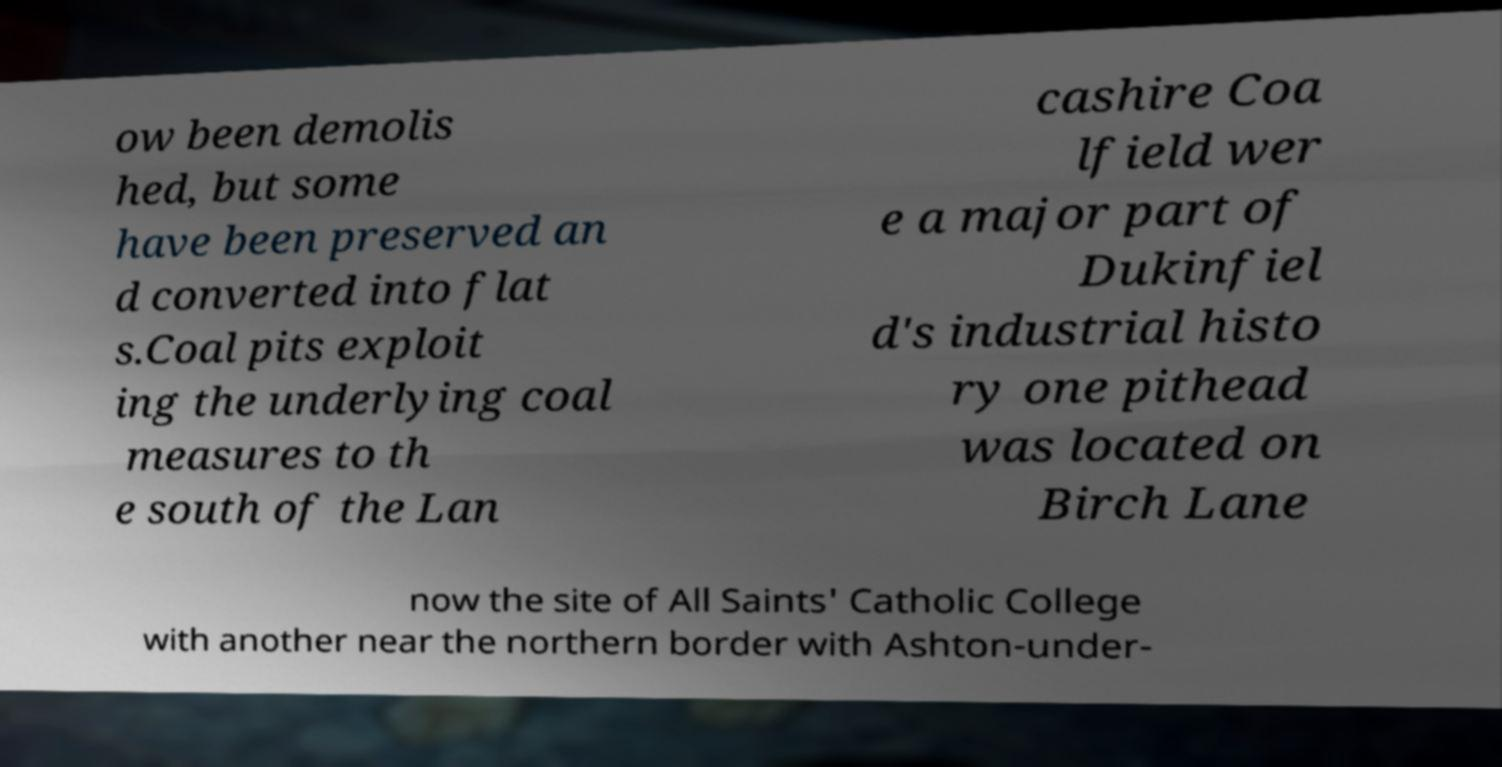There's text embedded in this image that I need extracted. Can you transcribe it verbatim? ow been demolis hed, but some have been preserved an d converted into flat s.Coal pits exploit ing the underlying coal measures to th e south of the Lan cashire Coa lfield wer e a major part of Dukinfiel d's industrial histo ry one pithead was located on Birch Lane now the site of All Saints' Catholic College with another near the northern border with Ashton-under- 